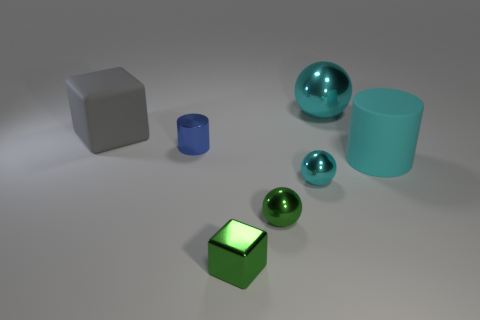How many objects are large cylinders or small blue matte cylinders?
Offer a very short reply. 1. What is the size of the green object that is the same shape as the big gray rubber thing?
Offer a terse response. Small. Are there more small blue objects in front of the tiny block than green metal balls?
Offer a terse response. No. Does the tiny cube have the same material as the cyan cylinder?
Offer a terse response. No. What number of things are green shiny spheres to the right of the green metallic block or shiny objects in front of the cyan rubber thing?
Your answer should be compact. 3. What is the color of the other metallic object that is the same shape as the big gray thing?
Give a very brief answer. Green. How many rubber cubes are the same color as the tiny cylinder?
Your answer should be very brief. 0. Is the color of the tiny metal cylinder the same as the matte block?
Keep it short and to the point. No. What number of things are either metallic balls that are on the left side of the big cyan ball or tiny blue objects?
Your response must be concise. 3. What is the color of the sphere that is behind the rubber object behind the cyan matte cylinder that is right of the big gray object?
Ensure brevity in your answer.  Cyan. 